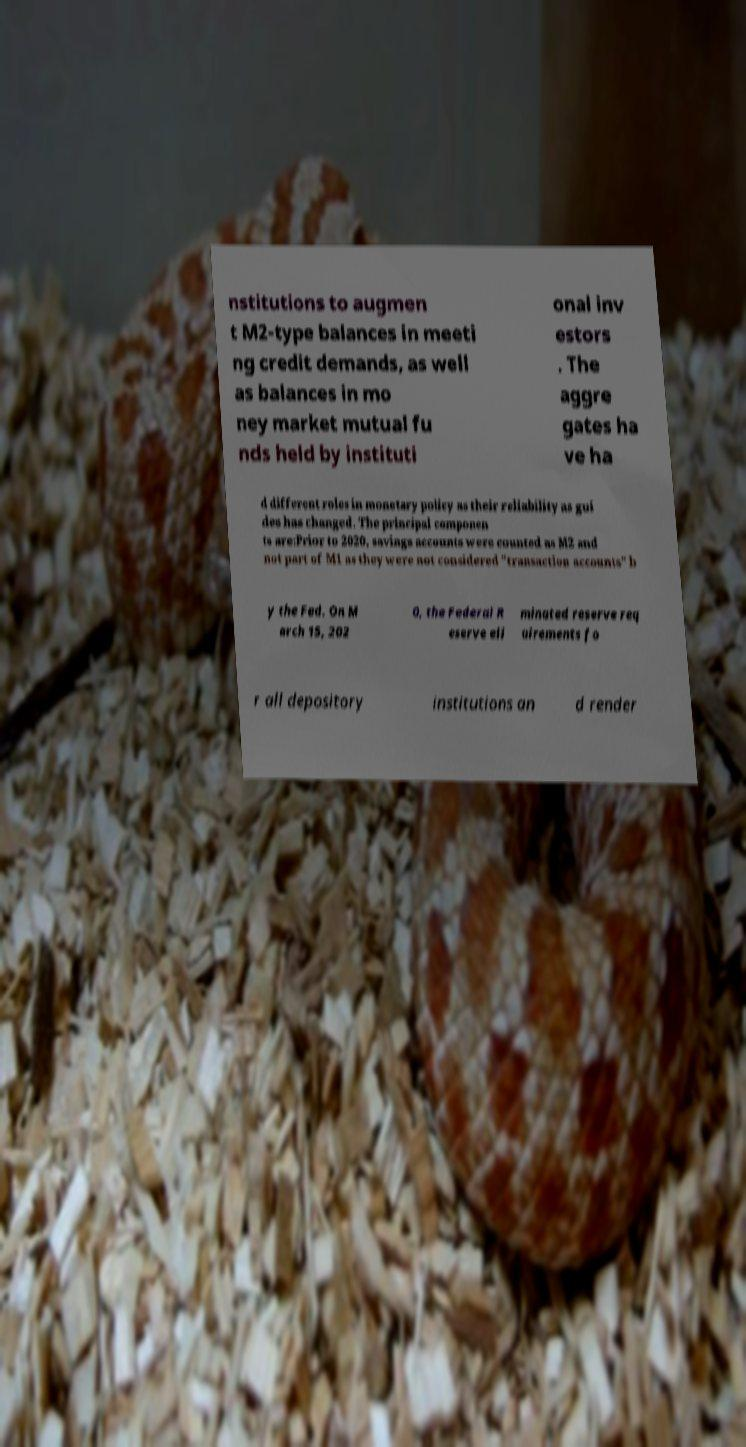Could you assist in decoding the text presented in this image and type it out clearly? nstitutions to augmen t M2-type balances in meeti ng credit demands, as well as balances in mo ney market mutual fu nds held by instituti onal inv estors . The aggre gates ha ve ha d different roles in monetary policy as their reliability as gui des has changed. The principal componen ts are:Prior to 2020, savings accounts were counted as M2 and not part of M1 as they were not considered "transaction accounts" b y the Fed. On M arch 15, 202 0, the Federal R eserve eli minated reserve req uirements fo r all depository institutions an d render 